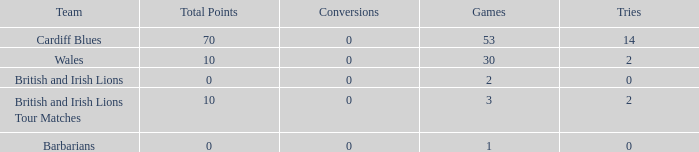What is the average number of tries for British and Irish Lions with less than 2 games? None. 